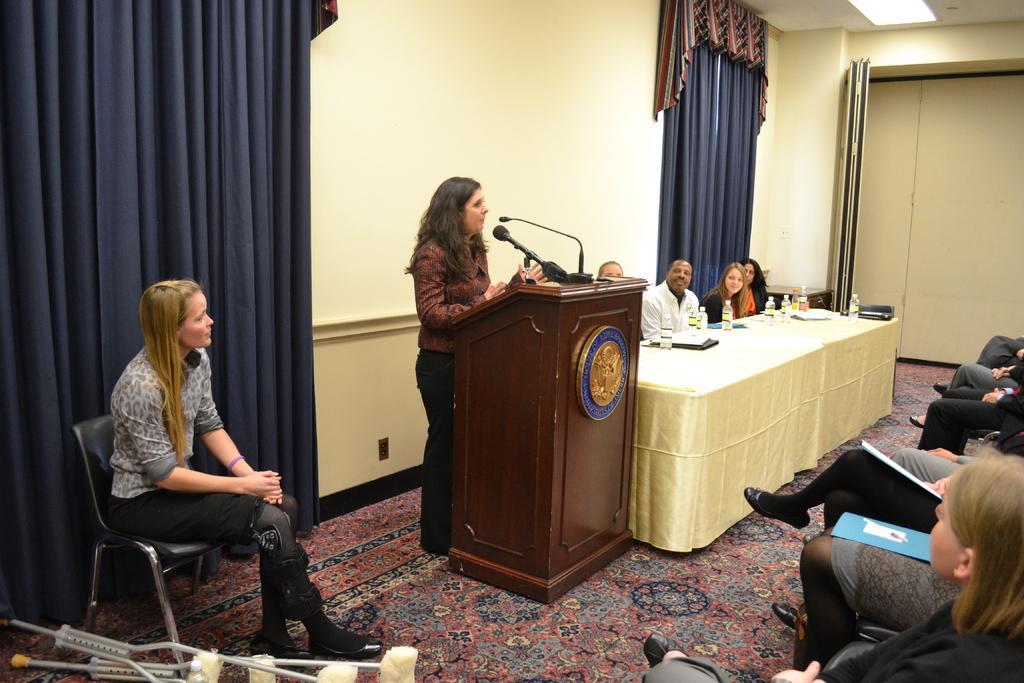Please provide a concise description of this image. In the picture we can see a meeting hall with a desk and some people sitting near it and on it we can see some water bottles and some papers and beside it, we can see a microphone desk with a microphone and a woman standing and talking and beside her we can see another woman sitting on the chair and in front of them, we can see some people sitting in the chairs and holding some papers and files, in the background we can see a wall with curtains which are blue in color and a wall which is cream in color. 